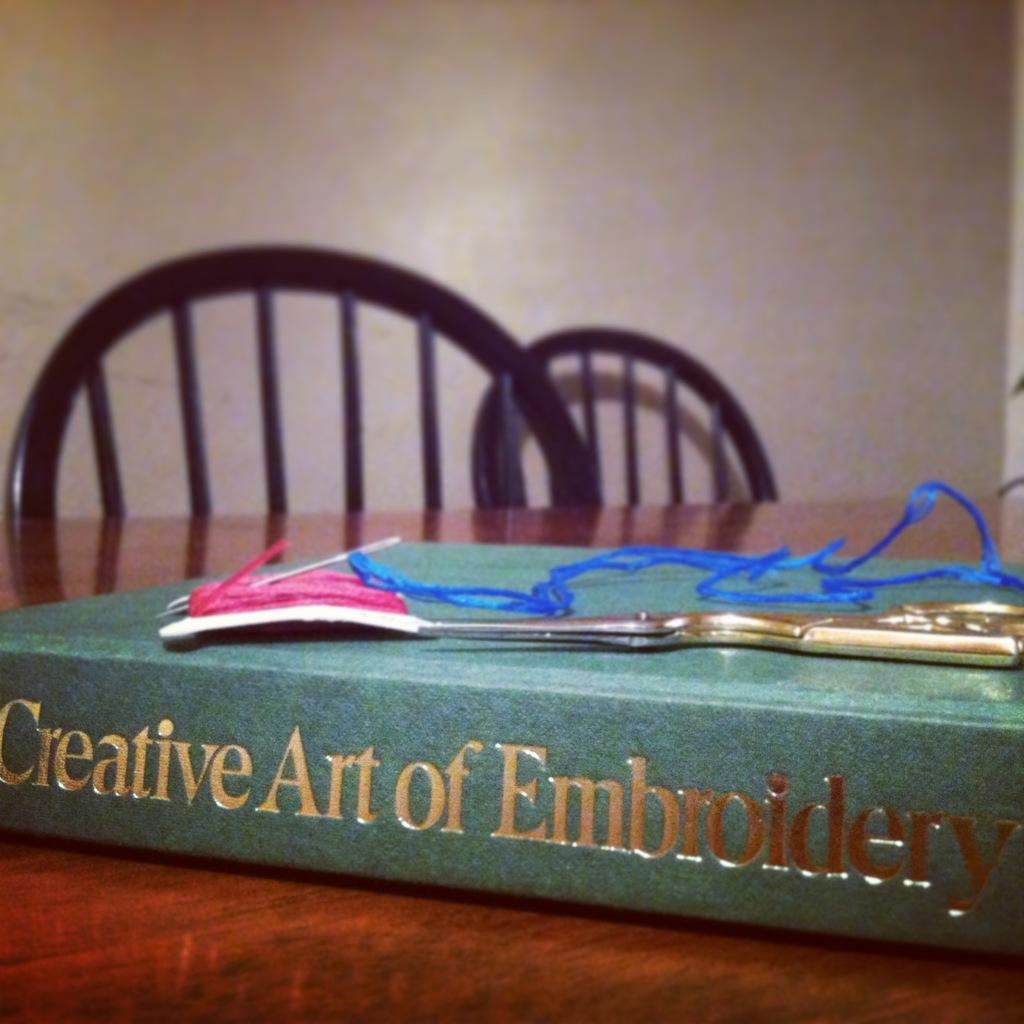What´s on top of the book?
Ensure brevity in your answer.  Scissors. 